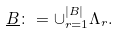<formula> <loc_0><loc_0><loc_500><loc_500>\underline { B } \colon = \cup _ { r = 1 } ^ { | B | } \Lambda _ { r } .</formula> 